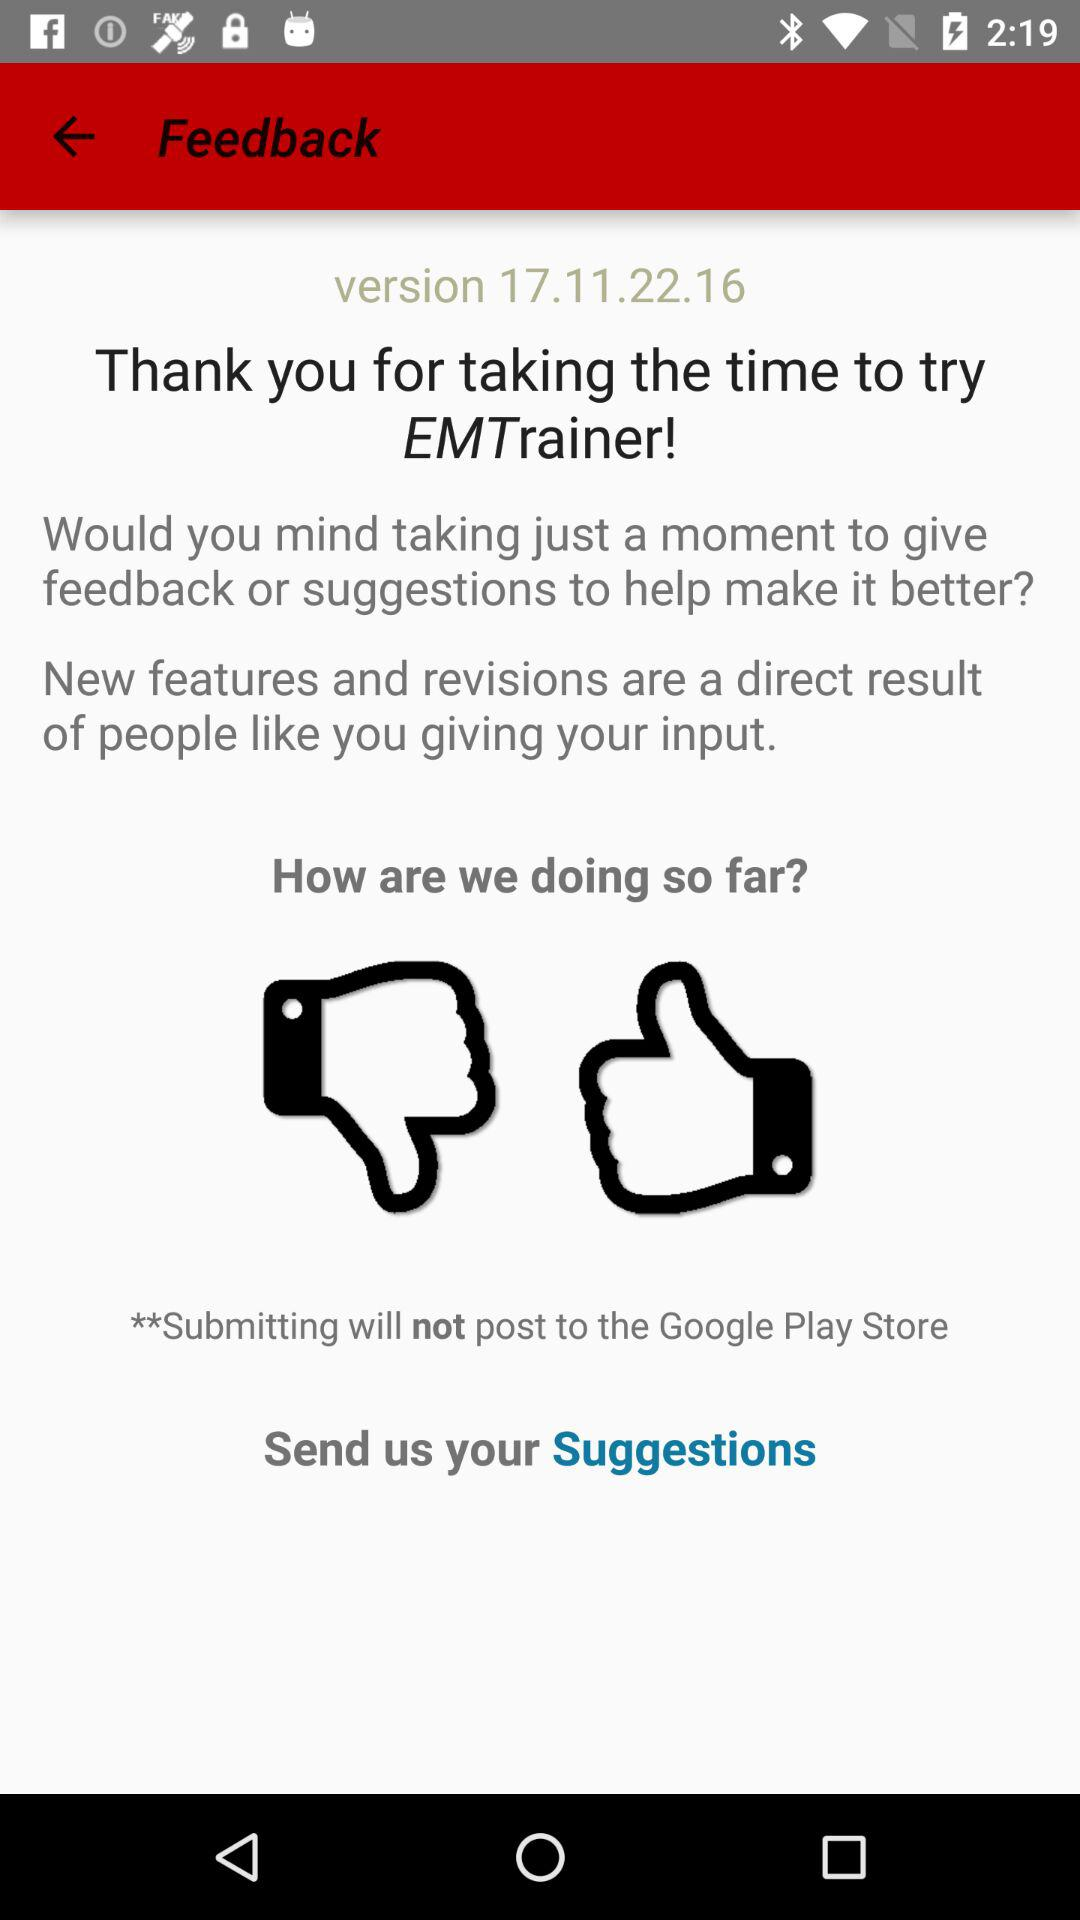Which version of the application is used? The used version is 17.11.22.16. 